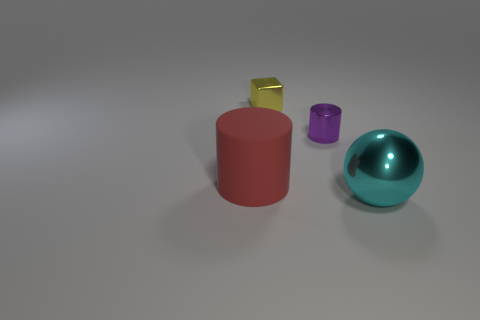Add 1 large green metallic blocks. How many objects exist? 5 Subtract 0 purple blocks. How many objects are left? 4 Subtract all cubes. How many objects are left? 3 Subtract all brown blocks. Subtract all red spheres. How many blocks are left? 1 Subtract all metal blocks. Subtract all red matte cylinders. How many objects are left? 2 Add 4 tiny blocks. How many tiny blocks are left? 5 Add 3 big red matte cylinders. How many big red matte cylinders exist? 4 